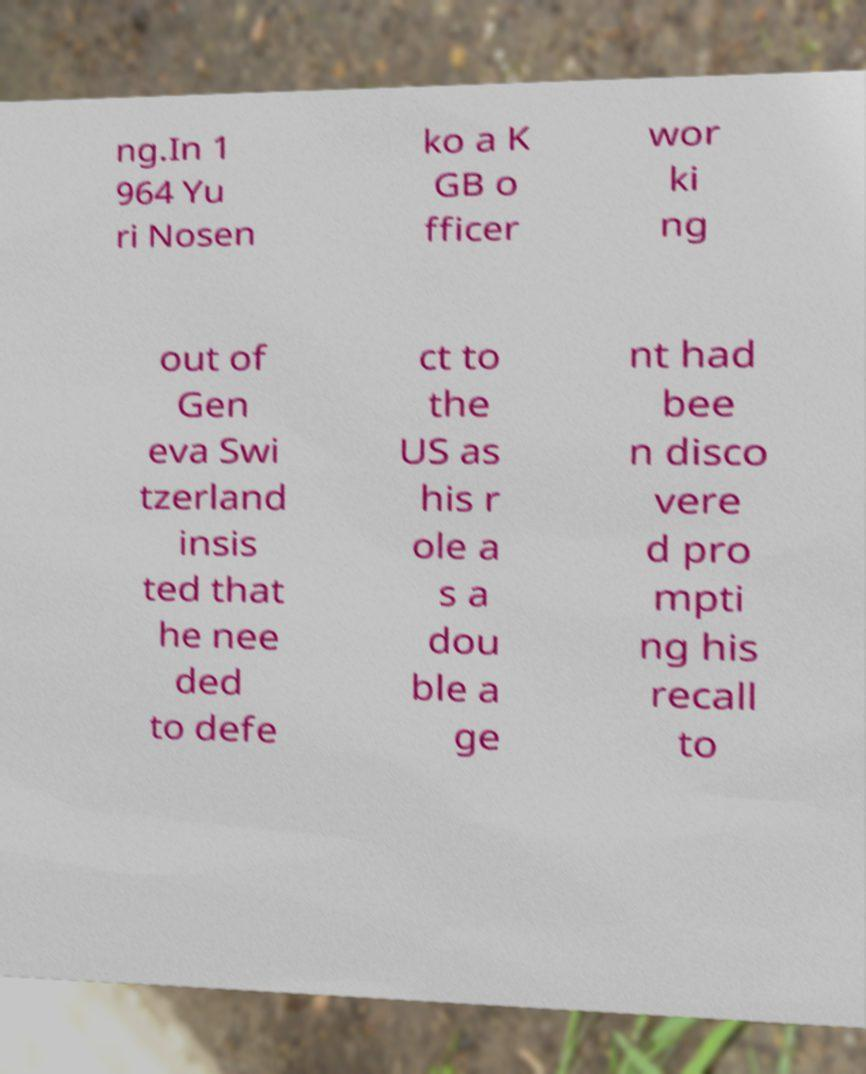Could you extract and type out the text from this image? ng.In 1 964 Yu ri Nosen ko a K GB o fficer wor ki ng out of Gen eva Swi tzerland insis ted that he nee ded to defe ct to the US as his r ole a s a dou ble a ge nt had bee n disco vere d pro mpti ng his recall to 